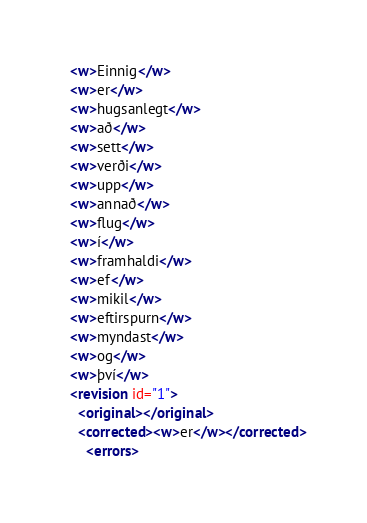<code> <loc_0><loc_0><loc_500><loc_500><_XML_>  <w>Einnig</w>
  <w>er</w>
  <w>hugsanlegt</w>
  <w>að</w>
  <w>sett</w>
  <w>verði</w>
  <w>upp</w>
  <w>annað</w>
  <w>flug</w>
  <w>í</w>
  <w>framhaldi</w>
  <w>ef</w>
  <w>mikil</w>
  <w>eftirspurn</w>
  <w>myndast</w>
  <w>og</w>
  <w>því</w>
  <revision id="1">
    <original></original>
    <corrected><w>er</w></corrected>
      <errors></code> 